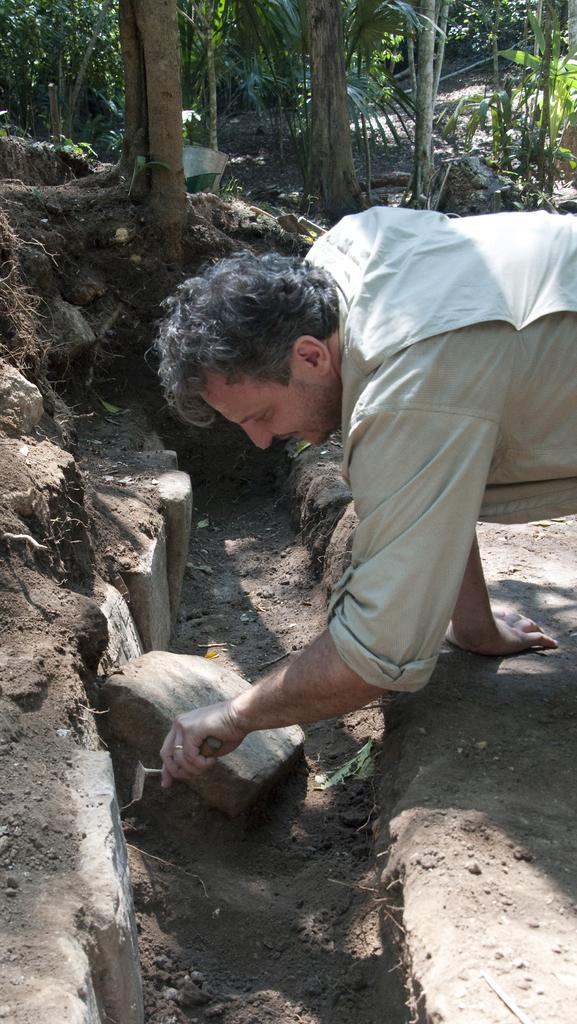What is the main subject of the image? There is a person in the image. What is the person holding in their hand? The person is holding a tool in their hand. What is the person doing with the tool? The person is digging in the mud with the tool. What can be seen in the background of the image? There are trees visible in the background of the image. What other objects are present in the image? There are rocks present in the image. What type of stamp can be seen on the rocks in the image? There is no stamp present on the rocks in the image. What activity is the person participating in with the basket in the image? There is no basket present in the image, and the person is digging in the mud with a tool. 